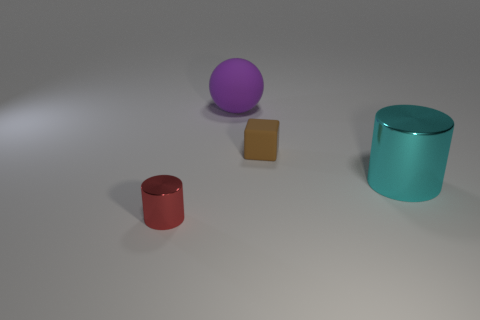What number of purple balls have the same size as the cyan metallic object?
Offer a very short reply. 1. How big is the cylinder that is behind the metal cylinder that is left of the large matte object?
Provide a short and direct response. Large. Do the big object to the left of the big cyan shiny cylinder and the tiny object that is behind the red thing have the same shape?
Ensure brevity in your answer.  No. There is a object that is in front of the tiny rubber block and on the right side of the red thing; what color is it?
Offer a very short reply. Cyan. Is there a big matte object that has the same color as the small cylinder?
Your response must be concise. No. There is a cylinder that is to the right of the brown object; what is its color?
Give a very brief answer. Cyan. Are there any brown blocks behind the ball that is right of the tiny cylinder?
Your answer should be compact. No. There is a tiny block; does it have the same color as the cylinder that is right of the purple ball?
Provide a succinct answer. No. Are there any cyan cylinders made of the same material as the brown cube?
Offer a terse response. No. What number of tiny green rubber cylinders are there?
Your response must be concise. 0. 